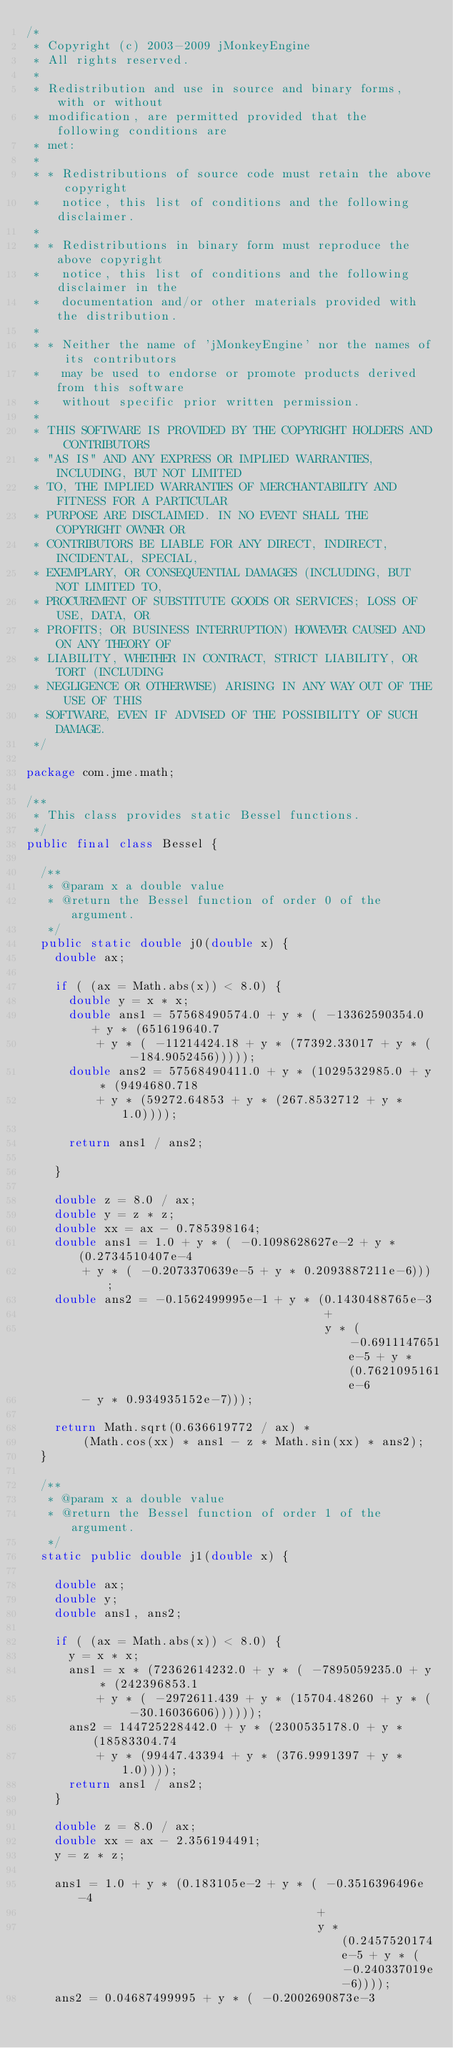Convert code to text. <code><loc_0><loc_0><loc_500><loc_500><_Java_>/*
 * Copyright (c) 2003-2009 jMonkeyEngine
 * All rights reserved.
 *
 * Redistribution and use in source and binary forms, with or without
 * modification, are permitted provided that the following conditions are
 * met:
 *
 * * Redistributions of source code must retain the above copyright
 *   notice, this list of conditions and the following disclaimer.
 *
 * * Redistributions in binary form must reproduce the above copyright
 *   notice, this list of conditions and the following disclaimer in the
 *   documentation and/or other materials provided with the distribution.
 *
 * * Neither the name of 'jMonkeyEngine' nor the names of its contributors 
 *   may be used to endorse or promote products derived from this software 
 *   without specific prior written permission.
 *
 * THIS SOFTWARE IS PROVIDED BY THE COPYRIGHT HOLDERS AND CONTRIBUTORS
 * "AS IS" AND ANY EXPRESS OR IMPLIED WARRANTIES, INCLUDING, BUT NOT LIMITED
 * TO, THE IMPLIED WARRANTIES OF MERCHANTABILITY AND FITNESS FOR A PARTICULAR
 * PURPOSE ARE DISCLAIMED. IN NO EVENT SHALL THE COPYRIGHT OWNER OR
 * CONTRIBUTORS BE LIABLE FOR ANY DIRECT, INDIRECT, INCIDENTAL, SPECIAL,
 * EXEMPLARY, OR CONSEQUENTIAL DAMAGES (INCLUDING, BUT NOT LIMITED TO,
 * PROCUREMENT OF SUBSTITUTE GOODS OR SERVICES; LOSS OF USE, DATA, OR
 * PROFITS; OR BUSINESS INTERRUPTION) HOWEVER CAUSED AND ON ANY THEORY OF
 * LIABILITY, WHETHER IN CONTRACT, STRICT LIABILITY, OR TORT (INCLUDING
 * NEGLIGENCE OR OTHERWISE) ARISING IN ANY WAY OUT OF THE USE OF THIS
 * SOFTWARE, EVEN IF ADVISED OF THE POSSIBILITY OF SUCH DAMAGE.
 */

package com.jme.math;

/**
 * This class provides static Bessel functions.
 */
public final class Bessel {

  /**
   * @param x a double value
   * @return the Bessel function of order 0 of the argument.
   */
  public static double j0(double x) {
    double ax;

    if ( (ax = Math.abs(x)) < 8.0) {
      double y = x * x;
      double ans1 = 57568490574.0 + y * ( -13362590354.0 + y * (651619640.7
          + y * ( -11214424.18 + y * (77392.33017 + y * ( -184.9052456)))));
      double ans2 = 57568490411.0 + y * (1029532985.0 + y * (9494680.718
          + y * (59272.64853 + y * (267.8532712 + y * 1.0))));

      return ans1 / ans2;

    }
    
    double z = 8.0 / ax;
    double y = z * z;
    double xx = ax - 0.785398164;
    double ans1 = 1.0 + y * ( -0.1098628627e-2 + y * (0.2734510407e-4
        + y * ( -0.2073370639e-5 + y * 0.2093887211e-6)));
    double ans2 = -0.1562499995e-1 + y * (0.1430488765e-3
                                          +
                                          y * ( -0.6911147651e-5 + y * (0.7621095161e-6
        - y * 0.934935152e-7)));

    return Math.sqrt(0.636619772 / ax) *
        (Math.cos(xx) * ans1 - z * Math.sin(xx) * ans2);    
  }

  /**
   * @param x a double value
   * @return the Bessel function of order 1 of the argument.
   */
  static public double j1(double x) {

    double ax;
    double y;
    double ans1, ans2;

    if ( (ax = Math.abs(x)) < 8.0) {
      y = x * x;
      ans1 = x * (72362614232.0 + y * ( -7895059235.0 + y * (242396853.1
          + y * ( -2972611.439 + y * (15704.48260 + y * ( -30.16036606))))));
      ans2 = 144725228442.0 + y * (2300535178.0 + y * (18583304.74
          + y * (99447.43394 + y * (376.9991397 + y * 1.0))));
      return ans1 / ans2;
    }
    
    double z = 8.0 / ax;
    double xx = ax - 2.356194491;
    y = z * z;

    ans1 = 1.0 + y * (0.183105e-2 + y * ( -0.3516396496e-4
                                         +
                                         y * (0.2457520174e-5 + y * ( -0.240337019e-6))));
    ans2 = 0.04687499995 + y * ( -0.2002690873e-3</code> 